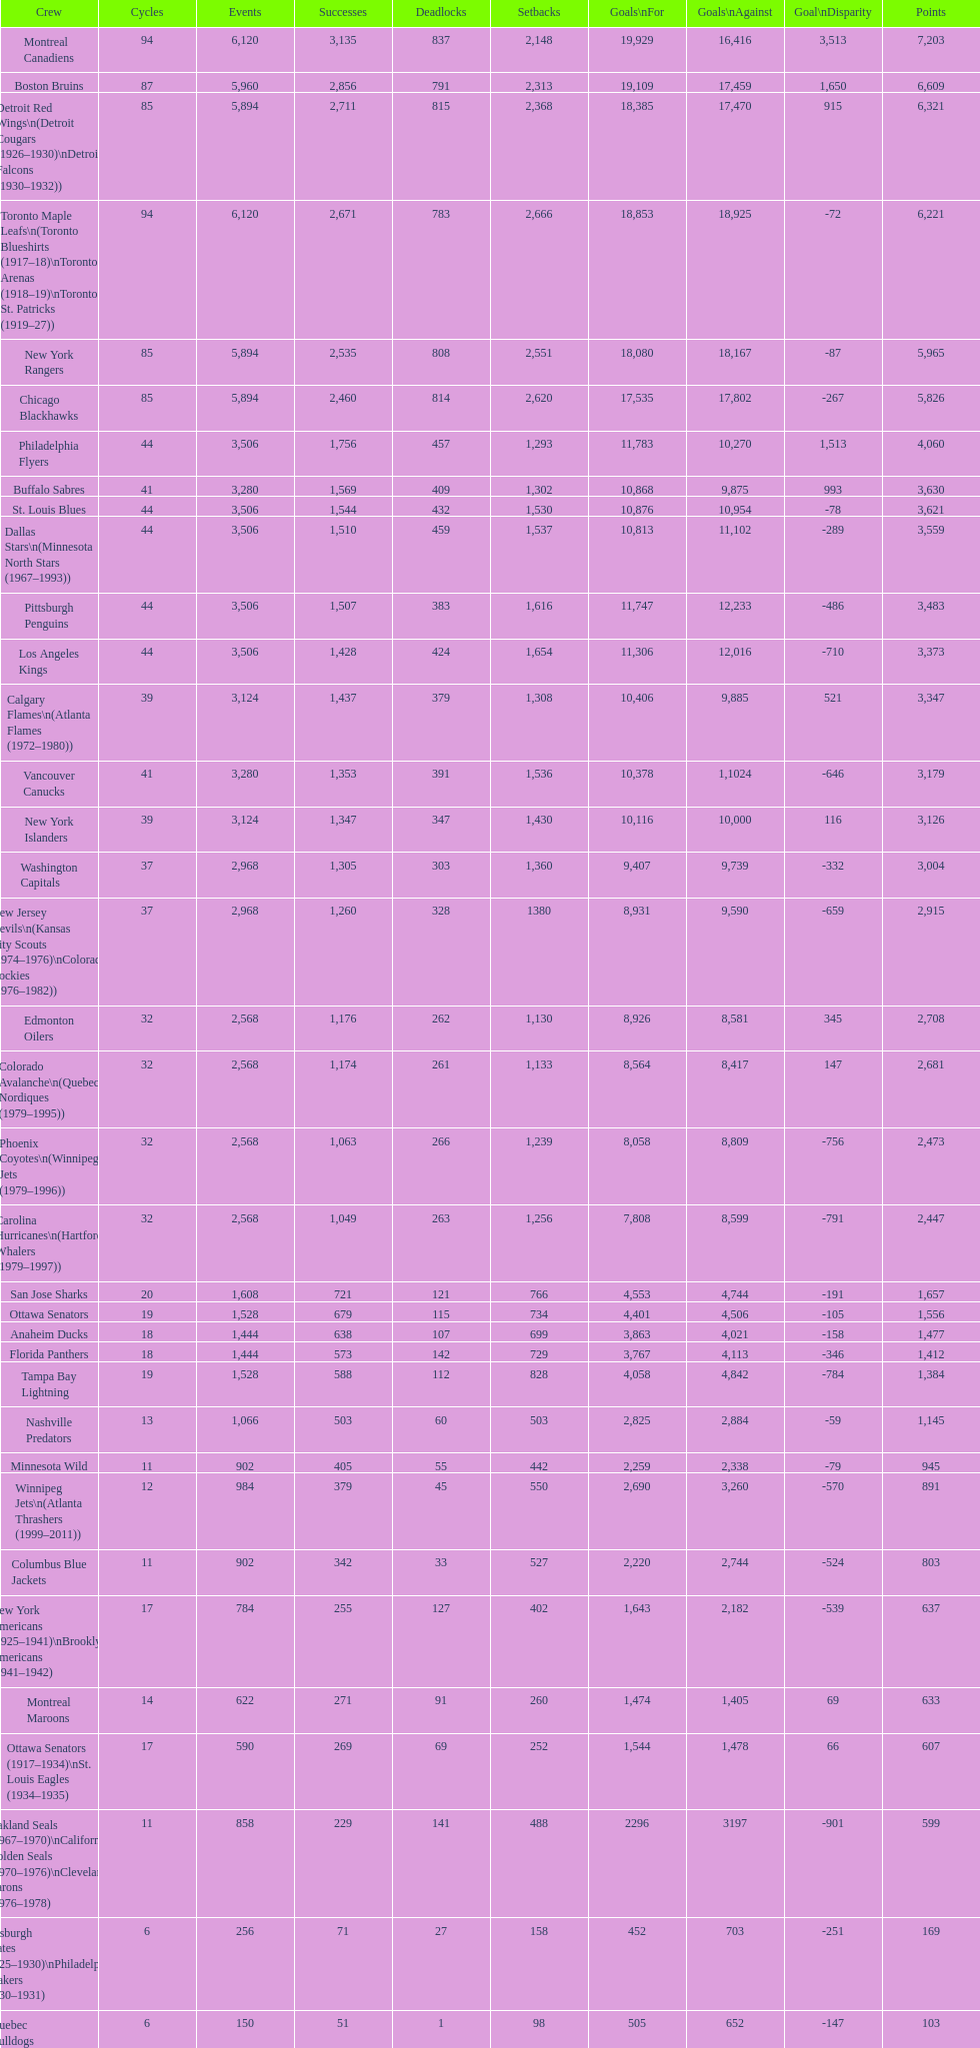How many teams have won more than 1,500 games? 11. 